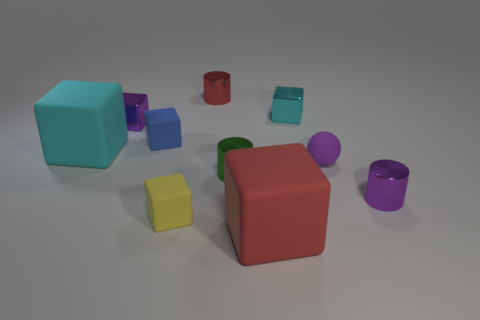Subtract all red shiny cylinders. How many cylinders are left? 2 Subtract all spheres. How many objects are left? 9 Subtract all yellow blocks. Subtract all red cylinders. How many blocks are left? 5 Subtract all yellow blocks. How many green spheres are left? 0 Subtract all rubber balls. Subtract all large red cubes. How many objects are left? 8 Add 8 small shiny cubes. How many small shiny cubes are left? 10 Add 6 big blue cubes. How many big blue cubes exist? 6 Subtract all blue cubes. How many cubes are left? 5 Subtract 1 red cylinders. How many objects are left? 9 Subtract 1 cylinders. How many cylinders are left? 2 